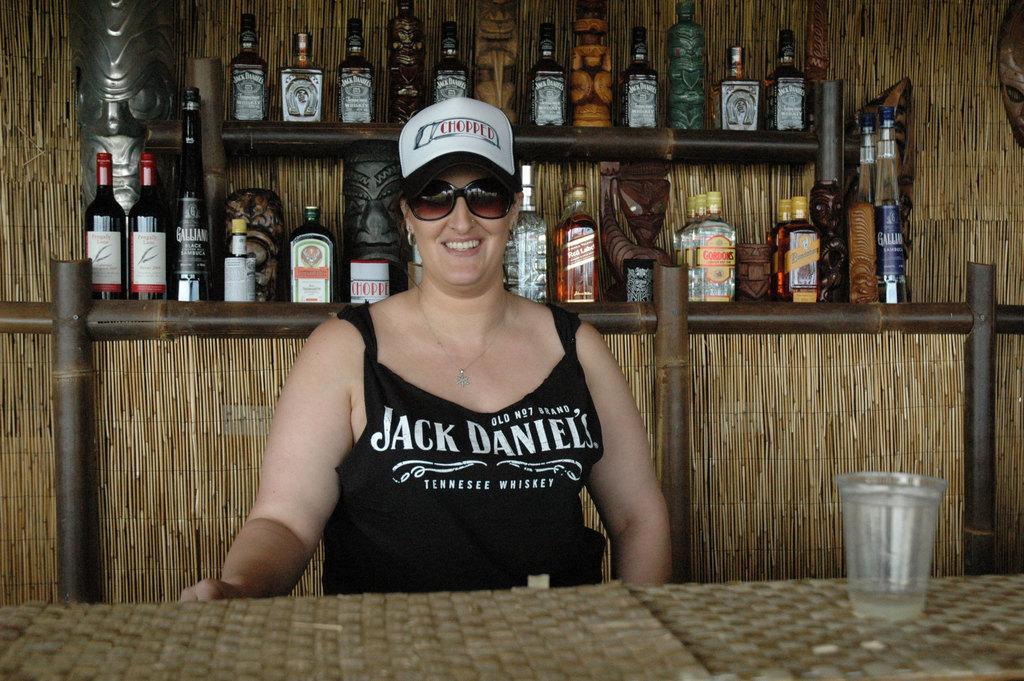Could you give a brief overview of what you see in this image? A woman is posing to camera with some wine bottles in her background. 